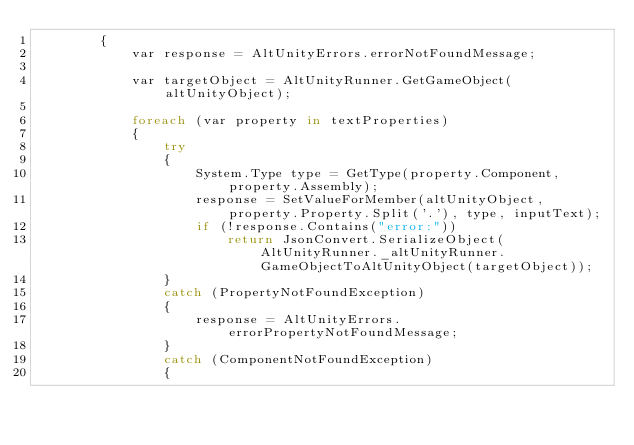Convert code to text. <code><loc_0><loc_0><loc_500><loc_500><_C#_>        {
            var response = AltUnityErrors.errorNotFoundMessage;

            var targetObject = AltUnityRunner.GetGameObject(altUnityObject);

            foreach (var property in textProperties)
            {
                try
                {
                    System.Type type = GetType(property.Component, property.Assembly);
                    response = SetValueForMember(altUnityObject, property.Property.Split('.'), type, inputText);
                    if (!response.Contains("error:"))
                        return JsonConvert.SerializeObject(AltUnityRunner._altUnityRunner.GameObjectToAltUnityObject(targetObject));
                }
                catch (PropertyNotFoundException)
                {
                    response = AltUnityErrors.errorPropertyNotFoundMessage;
                }
                catch (ComponentNotFoundException)
                {</code> 